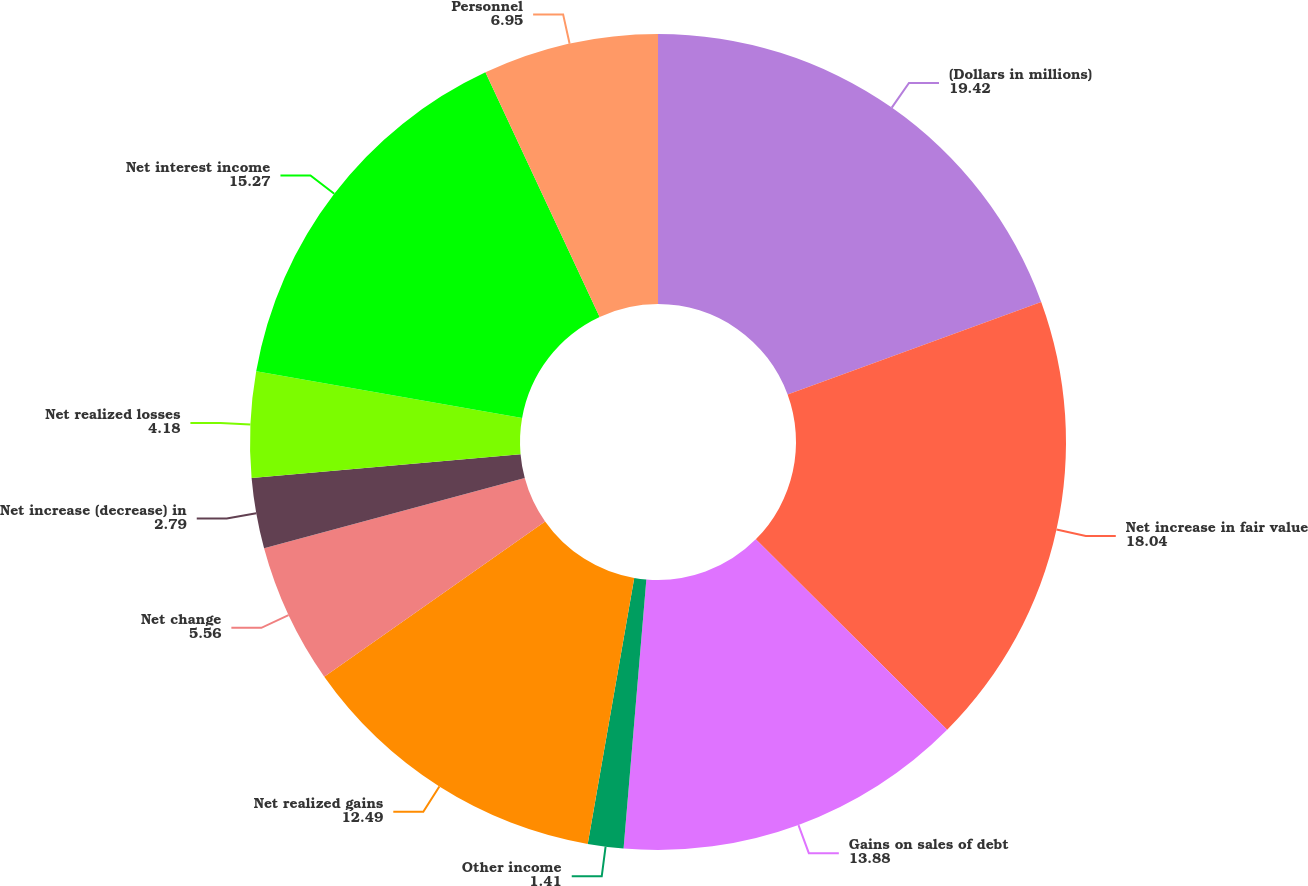Convert chart. <chart><loc_0><loc_0><loc_500><loc_500><pie_chart><fcel>(Dollars in millions)<fcel>Net increase in fair value<fcel>Gains on sales of debt<fcel>Other income<fcel>Net realized gains<fcel>Net change<fcel>Net increase (decrease) in<fcel>Net realized losses<fcel>Net interest income<fcel>Personnel<nl><fcel>19.42%<fcel>18.04%<fcel>13.88%<fcel>1.41%<fcel>12.49%<fcel>5.56%<fcel>2.79%<fcel>4.18%<fcel>15.27%<fcel>6.95%<nl></chart> 